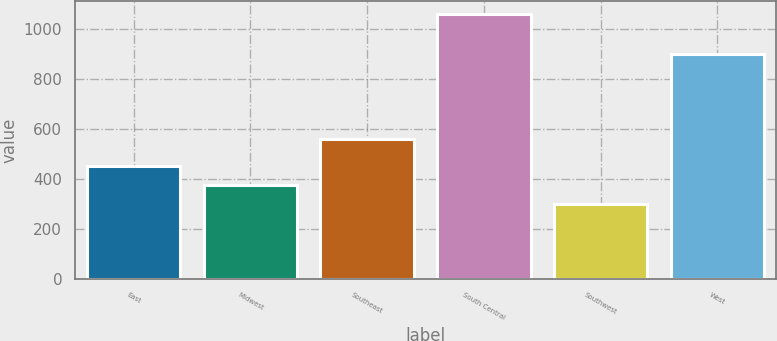<chart> <loc_0><loc_0><loc_500><loc_500><bar_chart><fcel>East<fcel>Midwest<fcel>Southeast<fcel>South Central<fcel>Southwest<fcel>West<nl><fcel>452.28<fcel>376.24<fcel>560.8<fcel>1060.6<fcel>300.2<fcel>899.6<nl></chart> 